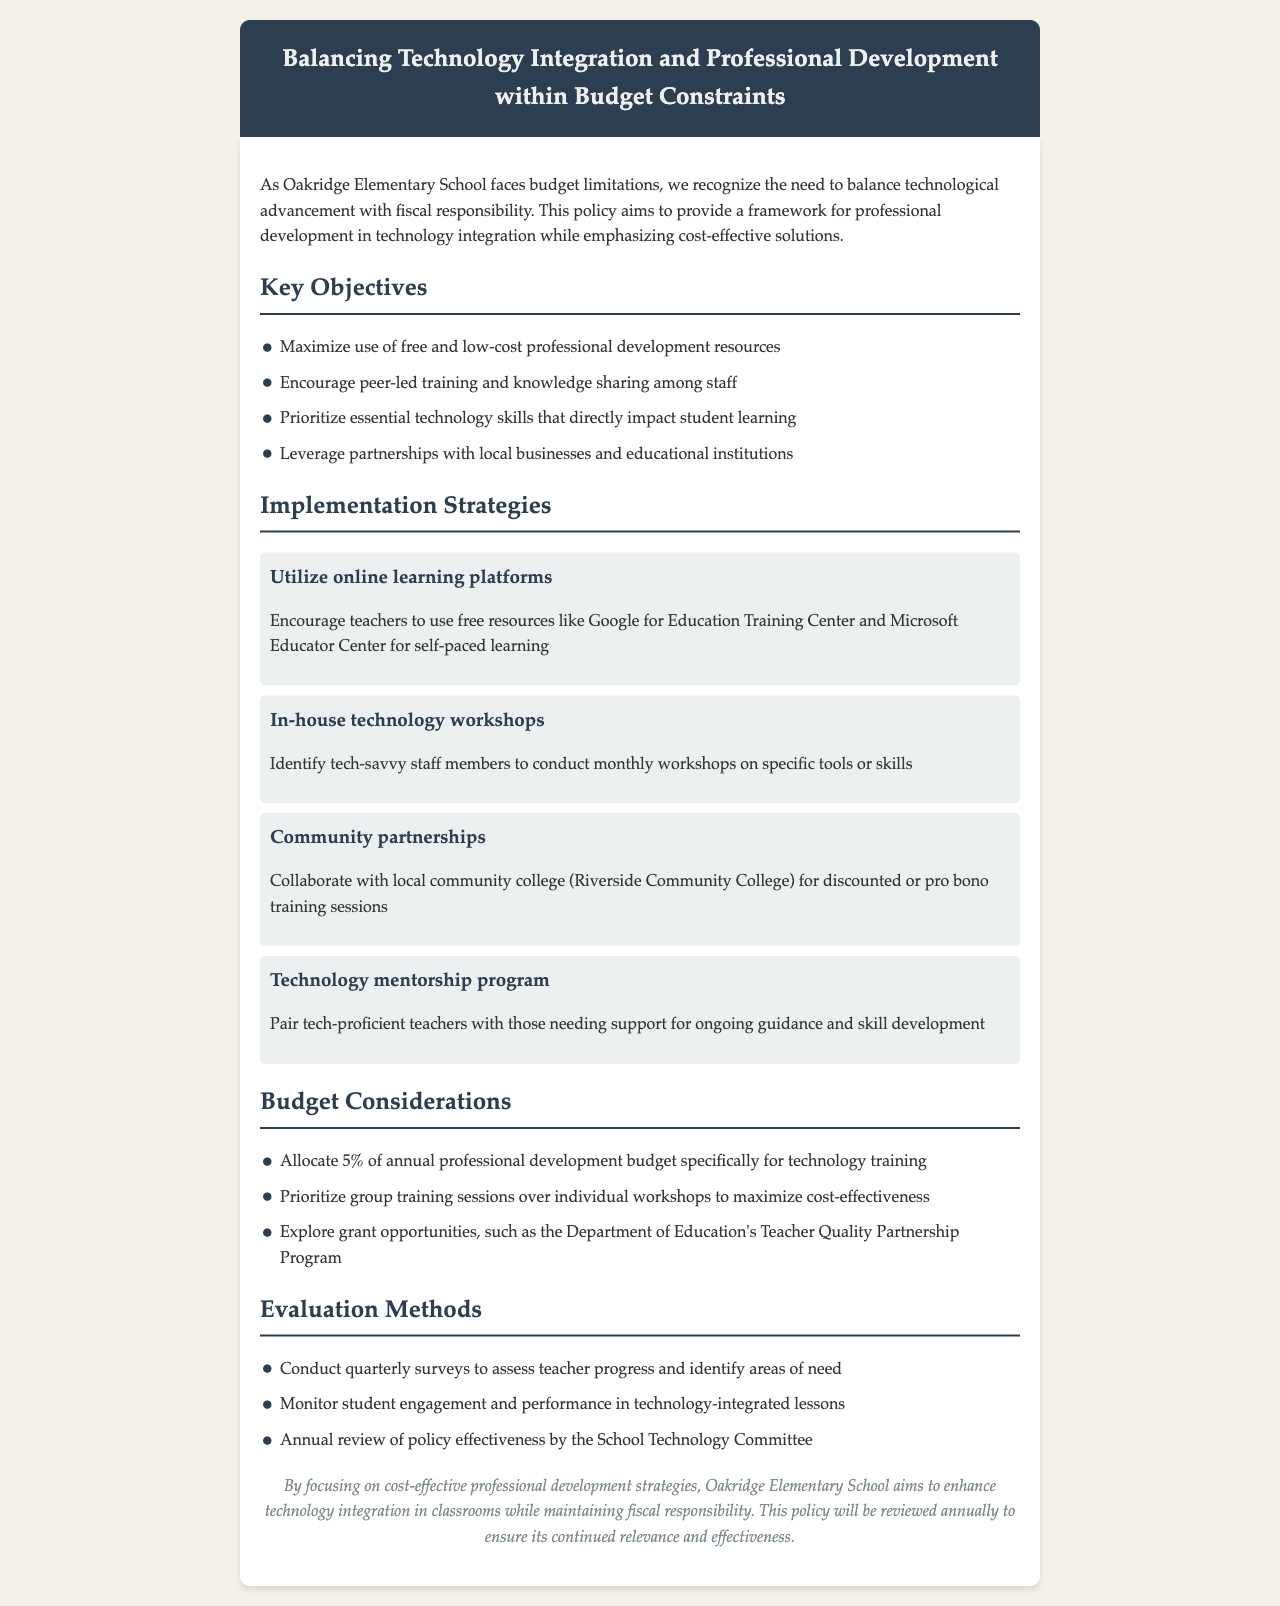What is the title of the policy document? The title is listed prominently at the top of the document, indicating the focus on balancing technology integration with budget considerations.
Answer: Balancing Technology Integration and Professional Development within Budget Constraints What percentage of the annual professional development budget is allocated for technology training? The document specifically mentions the allocation percentage under budget considerations.
Answer: 5% Which organization is mentioned for exploring grant opportunities in the document? The document references this organization in the budget considerations section as a potential resource for funding.
Answer: Department of Education What is one strategy for professional development proposed in the document? The document outlines multiple strategies for training, emphasizing cost-effective options while enhancing technology use.
Answer: Utilize online learning platforms How often will the policy be reviewed for effectiveness? The conclusion of the document states the frequency of the policy review to ensure it remains relevant and effective.
Answer: Annually Who is suggested to conduct the in-house technology workshops? The document specifies a key group responsible for leading these workshops in the implementation strategies.
Answer: Tech-savvy staff members What community partnership is mentioned in the document? The document discusses collaboration with a local institution in the context of training sessions to enhance technology skills.
Answer: Riverside Community College How will teacher progress be assessed according to the document? The evaluation methods include specific actions taken to monitor teacher development and needs within technology integration.
Answer: Conduct quarterly surveys 